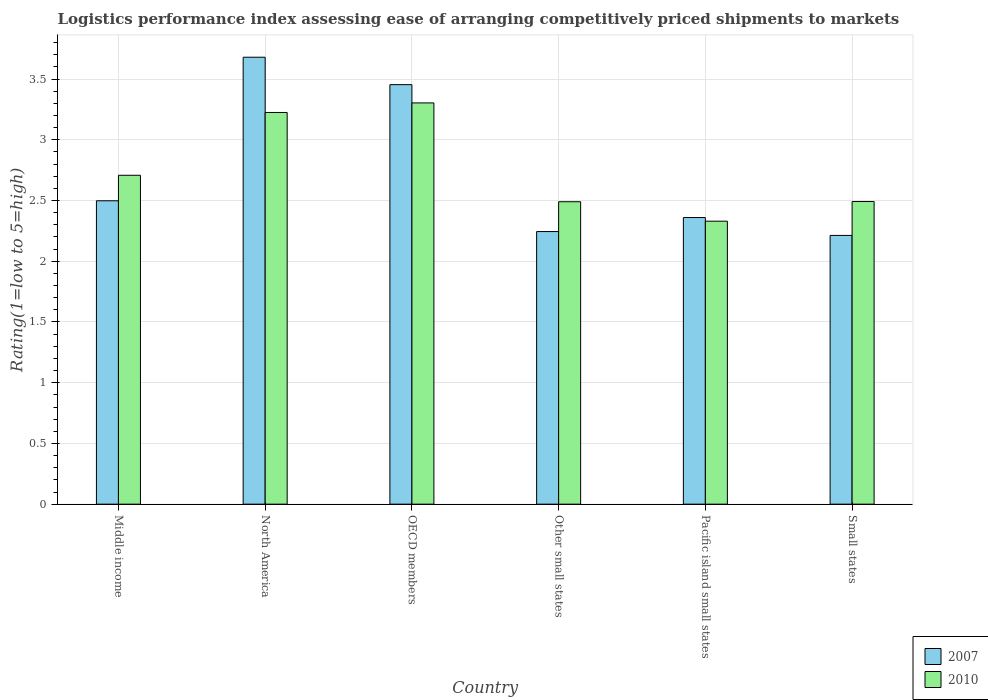How many different coloured bars are there?
Give a very brief answer. 2. How many bars are there on the 4th tick from the right?
Provide a short and direct response. 2. What is the label of the 5th group of bars from the left?
Ensure brevity in your answer.  Pacific island small states. In how many cases, is the number of bars for a given country not equal to the number of legend labels?
Keep it short and to the point. 0. What is the Logistic performance index in 2010 in North America?
Give a very brief answer. 3.23. Across all countries, what is the maximum Logistic performance index in 2010?
Your answer should be very brief. 3.3. Across all countries, what is the minimum Logistic performance index in 2010?
Provide a succinct answer. 2.33. In which country was the Logistic performance index in 2007 maximum?
Your response must be concise. North America. In which country was the Logistic performance index in 2010 minimum?
Your answer should be very brief. Pacific island small states. What is the total Logistic performance index in 2010 in the graph?
Offer a very short reply. 16.55. What is the difference between the Logistic performance index in 2010 in North America and that in Small states?
Provide a succinct answer. 0.73. What is the difference between the Logistic performance index in 2010 in Pacific island small states and the Logistic performance index in 2007 in OECD members?
Your answer should be very brief. -1.12. What is the average Logistic performance index in 2007 per country?
Offer a very short reply. 2.74. What is the difference between the Logistic performance index of/in 2010 and Logistic performance index of/in 2007 in North America?
Give a very brief answer. -0.46. What is the ratio of the Logistic performance index in 2007 in OECD members to that in Other small states?
Offer a very short reply. 1.54. Is the Logistic performance index in 2007 in Other small states less than that in Pacific island small states?
Give a very brief answer. Yes. Is the difference between the Logistic performance index in 2010 in OECD members and Pacific island small states greater than the difference between the Logistic performance index in 2007 in OECD members and Pacific island small states?
Provide a short and direct response. No. What is the difference between the highest and the second highest Logistic performance index in 2010?
Offer a very short reply. 0.52. What is the difference between the highest and the lowest Logistic performance index in 2007?
Keep it short and to the point. 1.47. What does the 2nd bar from the right in Other small states represents?
Offer a terse response. 2007. How many bars are there?
Ensure brevity in your answer.  12. Are all the bars in the graph horizontal?
Make the answer very short. No. How many countries are there in the graph?
Make the answer very short. 6. What is the difference between two consecutive major ticks on the Y-axis?
Offer a terse response. 0.5. Does the graph contain any zero values?
Make the answer very short. No. Does the graph contain grids?
Give a very brief answer. Yes. Where does the legend appear in the graph?
Give a very brief answer. Bottom right. How many legend labels are there?
Provide a succinct answer. 2. What is the title of the graph?
Offer a terse response. Logistics performance index assessing ease of arranging competitively priced shipments to markets. What is the label or title of the X-axis?
Provide a short and direct response. Country. What is the label or title of the Y-axis?
Offer a terse response. Rating(1=low to 5=high). What is the Rating(1=low to 5=high) in 2007 in Middle income?
Your response must be concise. 2.5. What is the Rating(1=low to 5=high) in 2010 in Middle income?
Offer a terse response. 2.71. What is the Rating(1=low to 5=high) in 2007 in North America?
Offer a terse response. 3.68. What is the Rating(1=low to 5=high) of 2010 in North America?
Make the answer very short. 3.23. What is the Rating(1=low to 5=high) in 2007 in OECD members?
Keep it short and to the point. 3.45. What is the Rating(1=low to 5=high) of 2010 in OECD members?
Give a very brief answer. 3.3. What is the Rating(1=low to 5=high) in 2007 in Other small states?
Your answer should be compact. 2.24. What is the Rating(1=low to 5=high) in 2010 in Other small states?
Your response must be concise. 2.49. What is the Rating(1=low to 5=high) of 2007 in Pacific island small states?
Ensure brevity in your answer.  2.36. What is the Rating(1=low to 5=high) of 2010 in Pacific island small states?
Your response must be concise. 2.33. What is the Rating(1=low to 5=high) of 2007 in Small states?
Provide a succinct answer. 2.21. What is the Rating(1=low to 5=high) in 2010 in Small states?
Ensure brevity in your answer.  2.49. Across all countries, what is the maximum Rating(1=low to 5=high) of 2007?
Provide a succinct answer. 3.68. Across all countries, what is the maximum Rating(1=low to 5=high) of 2010?
Provide a short and direct response. 3.3. Across all countries, what is the minimum Rating(1=low to 5=high) in 2007?
Make the answer very short. 2.21. Across all countries, what is the minimum Rating(1=low to 5=high) in 2010?
Offer a terse response. 2.33. What is the total Rating(1=low to 5=high) of 2007 in the graph?
Make the answer very short. 16.45. What is the total Rating(1=low to 5=high) in 2010 in the graph?
Ensure brevity in your answer.  16.55. What is the difference between the Rating(1=low to 5=high) in 2007 in Middle income and that in North America?
Offer a very short reply. -1.18. What is the difference between the Rating(1=low to 5=high) of 2010 in Middle income and that in North America?
Provide a short and direct response. -0.52. What is the difference between the Rating(1=low to 5=high) in 2007 in Middle income and that in OECD members?
Your response must be concise. -0.96. What is the difference between the Rating(1=low to 5=high) in 2010 in Middle income and that in OECD members?
Provide a succinct answer. -0.6. What is the difference between the Rating(1=low to 5=high) in 2007 in Middle income and that in Other small states?
Keep it short and to the point. 0.25. What is the difference between the Rating(1=low to 5=high) of 2010 in Middle income and that in Other small states?
Your response must be concise. 0.22. What is the difference between the Rating(1=low to 5=high) in 2007 in Middle income and that in Pacific island small states?
Offer a terse response. 0.14. What is the difference between the Rating(1=low to 5=high) of 2010 in Middle income and that in Pacific island small states?
Ensure brevity in your answer.  0.38. What is the difference between the Rating(1=low to 5=high) in 2007 in Middle income and that in Small states?
Offer a terse response. 0.29. What is the difference between the Rating(1=low to 5=high) of 2010 in Middle income and that in Small states?
Keep it short and to the point. 0.22. What is the difference between the Rating(1=low to 5=high) in 2007 in North America and that in OECD members?
Provide a short and direct response. 0.23. What is the difference between the Rating(1=low to 5=high) of 2010 in North America and that in OECD members?
Your answer should be very brief. -0.08. What is the difference between the Rating(1=low to 5=high) of 2007 in North America and that in Other small states?
Keep it short and to the point. 1.44. What is the difference between the Rating(1=low to 5=high) of 2010 in North America and that in Other small states?
Give a very brief answer. 0.73. What is the difference between the Rating(1=low to 5=high) in 2007 in North America and that in Pacific island small states?
Ensure brevity in your answer.  1.32. What is the difference between the Rating(1=low to 5=high) of 2010 in North America and that in Pacific island small states?
Give a very brief answer. 0.9. What is the difference between the Rating(1=low to 5=high) of 2007 in North America and that in Small states?
Provide a succinct answer. 1.47. What is the difference between the Rating(1=low to 5=high) of 2010 in North America and that in Small states?
Make the answer very short. 0.73. What is the difference between the Rating(1=low to 5=high) in 2007 in OECD members and that in Other small states?
Your answer should be very brief. 1.21. What is the difference between the Rating(1=low to 5=high) in 2010 in OECD members and that in Other small states?
Your answer should be compact. 0.81. What is the difference between the Rating(1=low to 5=high) in 2007 in OECD members and that in Pacific island small states?
Make the answer very short. 1.09. What is the difference between the Rating(1=low to 5=high) of 2010 in OECD members and that in Pacific island small states?
Give a very brief answer. 0.97. What is the difference between the Rating(1=low to 5=high) in 2007 in OECD members and that in Small states?
Your response must be concise. 1.24. What is the difference between the Rating(1=low to 5=high) of 2010 in OECD members and that in Small states?
Your answer should be compact. 0.81. What is the difference between the Rating(1=low to 5=high) in 2007 in Other small states and that in Pacific island small states?
Offer a very short reply. -0.12. What is the difference between the Rating(1=low to 5=high) of 2010 in Other small states and that in Pacific island small states?
Your response must be concise. 0.16. What is the difference between the Rating(1=low to 5=high) in 2007 in Other small states and that in Small states?
Keep it short and to the point. 0.03. What is the difference between the Rating(1=low to 5=high) in 2010 in Other small states and that in Small states?
Your answer should be very brief. -0. What is the difference between the Rating(1=low to 5=high) in 2007 in Pacific island small states and that in Small states?
Provide a short and direct response. 0.15. What is the difference between the Rating(1=low to 5=high) of 2010 in Pacific island small states and that in Small states?
Provide a short and direct response. -0.16. What is the difference between the Rating(1=low to 5=high) in 2007 in Middle income and the Rating(1=low to 5=high) in 2010 in North America?
Your answer should be compact. -0.73. What is the difference between the Rating(1=low to 5=high) of 2007 in Middle income and the Rating(1=low to 5=high) of 2010 in OECD members?
Offer a very short reply. -0.81. What is the difference between the Rating(1=low to 5=high) in 2007 in Middle income and the Rating(1=low to 5=high) in 2010 in Other small states?
Your answer should be very brief. 0.01. What is the difference between the Rating(1=low to 5=high) of 2007 in Middle income and the Rating(1=low to 5=high) of 2010 in Pacific island small states?
Offer a very short reply. 0.17. What is the difference between the Rating(1=low to 5=high) in 2007 in Middle income and the Rating(1=low to 5=high) in 2010 in Small states?
Make the answer very short. 0.01. What is the difference between the Rating(1=low to 5=high) in 2007 in North America and the Rating(1=low to 5=high) in 2010 in OECD members?
Make the answer very short. 0.38. What is the difference between the Rating(1=low to 5=high) of 2007 in North America and the Rating(1=low to 5=high) of 2010 in Other small states?
Provide a succinct answer. 1.19. What is the difference between the Rating(1=low to 5=high) of 2007 in North America and the Rating(1=low to 5=high) of 2010 in Pacific island small states?
Make the answer very short. 1.35. What is the difference between the Rating(1=low to 5=high) in 2007 in North America and the Rating(1=low to 5=high) in 2010 in Small states?
Provide a succinct answer. 1.19. What is the difference between the Rating(1=low to 5=high) of 2007 in OECD members and the Rating(1=low to 5=high) of 2010 in Other small states?
Ensure brevity in your answer.  0.96. What is the difference between the Rating(1=low to 5=high) of 2007 in OECD members and the Rating(1=low to 5=high) of 2010 in Pacific island small states?
Keep it short and to the point. 1.12. What is the difference between the Rating(1=low to 5=high) of 2007 in OECD members and the Rating(1=low to 5=high) of 2010 in Small states?
Provide a succinct answer. 0.96. What is the difference between the Rating(1=low to 5=high) in 2007 in Other small states and the Rating(1=low to 5=high) in 2010 in Pacific island small states?
Provide a short and direct response. -0.09. What is the difference between the Rating(1=low to 5=high) in 2007 in Other small states and the Rating(1=low to 5=high) in 2010 in Small states?
Provide a short and direct response. -0.25. What is the difference between the Rating(1=low to 5=high) in 2007 in Pacific island small states and the Rating(1=low to 5=high) in 2010 in Small states?
Provide a succinct answer. -0.13. What is the average Rating(1=low to 5=high) in 2007 per country?
Your answer should be very brief. 2.74. What is the average Rating(1=low to 5=high) of 2010 per country?
Ensure brevity in your answer.  2.76. What is the difference between the Rating(1=low to 5=high) in 2007 and Rating(1=low to 5=high) in 2010 in Middle income?
Give a very brief answer. -0.21. What is the difference between the Rating(1=low to 5=high) in 2007 and Rating(1=low to 5=high) in 2010 in North America?
Your answer should be very brief. 0.46. What is the difference between the Rating(1=low to 5=high) of 2007 and Rating(1=low to 5=high) of 2010 in OECD members?
Offer a very short reply. 0.15. What is the difference between the Rating(1=low to 5=high) of 2007 and Rating(1=low to 5=high) of 2010 in Other small states?
Provide a short and direct response. -0.25. What is the difference between the Rating(1=low to 5=high) in 2007 and Rating(1=low to 5=high) in 2010 in Small states?
Your answer should be compact. -0.28. What is the ratio of the Rating(1=low to 5=high) in 2007 in Middle income to that in North America?
Offer a very short reply. 0.68. What is the ratio of the Rating(1=low to 5=high) in 2010 in Middle income to that in North America?
Offer a very short reply. 0.84. What is the ratio of the Rating(1=low to 5=high) in 2007 in Middle income to that in OECD members?
Your answer should be very brief. 0.72. What is the ratio of the Rating(1=low to 5=high) in 2010 in Middle income to that in OECD members?
Offer a terse response. 0.82. What is the ratio of the Rating(1=low to 5=high) in 2007 in Middle income to that in Other small states?
Your answer should be very brief. 1.11. What is the ratio of the Rating(1=low to 5=high) in 2010 in Middle income to that in Other small states?
Give a very brief answer. 1.09. What is the ratio of the Rating(1=low to 5=high) in 2007 in Middle income to that in Pacific island small states?
Make the answer very short. 1.06. What is the ratio of the Rating(1=low to 5=high) in 2010 in Middle income to that in Pacific island small states?
Your answer should be very brief. 1.16. What is the ratio of the Rating(1=low to 5=high) in 2007 in Middle income to that in Small states?
Make the answer very short. 1.13. What is the ratio of the Rating(1=low to 5=high) in 2010 in Middle income to that in Small states?
Keep it short and to the point. 1.09. What is the ratio of the Rating(1=low to 5=high) of 2007 in North America to that in OECD members?
Your answer should be compact. 1.07. What is the ratio of the Rating(1=low to 5=high) in 2010 in North America to that in OECD members?
Provide a short and direct response. 0.98. What is the ratio of the Rating(1=low to 5=high) in 2007 in North America to that in Other small states?
Your answer should be compact. 1.64. What is the ratio of the Rating(1=low to 5=high) of 2010 in North America to that in Other small states?
Your answer should be very brief. 1.3. What is the ratio of the Rating(1=low to 5=high) in 2007 in North America to that in Pacific island small states?
Provide a short and direct response. 1.56. What is the ratio of the Rating(1=low to 5=high) in 2010 in North America to that in Pacific island small states?
Your response must be concise. 1.38. What is the ratio of the Rating(1=low to 5=high) in 2007 in North America to that in Small states?
Ensure brevity in your answer.  1.66. What is the ratio of the Rating(1=low to 5=high) of 2010 in North America to that in Small states?
Offer a very short reply. 1.29. What is the ratio of the Rating(1=low to 5=high) in 2007 in OECD members to that in Other small states?
Your answer should be very brief. 1.54. What is the ratio of the Rating(1=low to 5=high) in 2010 in OECD members to that in Other small states?
Your answer should be compact. 1.33. What is the ratio of the Rating(1=low to 5=high) of 2007 in OECD members to that in Pacific island small states?
Your response must be concise. 1.46. What is the ratio of the Rating(1=low to 5=high) of 2010 in OECD members to that in Pacific island small states?
Make the answer very short. 1.42. What is the ratio of the Rating(1=low to 5=high) in 2007 in OECD members to that in Small states?
Give a very brief answer. 1.56. What is the ratio of the Rating(1=low to 5=high) of 2010 in OECD members to that in Small states?
Your answer should be very brief. 1.33. What is the ratio of the Rating(1=low to 5=high) of 2007 in Other small states to that in Pacific island small states?
Offer a very short reply. 0.95. What is the ratio of the Rating(1=low to 5=high) of 2010 in Other small states to that in Pacific island small states?
Offer a very short reply. 1.07. What is the ratio of the Rating(1=low to 5=high) of 2007 in Other small states to that in Small states?
Provide a succinct answer. 1.01. What is the ratio of the Rating(1=low to 5=high) in 2007 in Pacific island small states to that in Small states?
Keep it short and to the point. 1.07. What is the ratio of the Rating(1=low to 5=high) in 2010 in Pacific island small states to that in Small states?
Ensure brevity in your answer.  0.94. What is the difference between the highest and the second highest Rating(1=low to 5=high) in 2007?
Your response must be concise. 0.23. What is the difference between the highest and the second highest Rating(1=low to 5=high) of 2010?
Your answer should be compact. 0.08. What is the difference between the highest and the lowest Rating(1=low to 5=high) in 2007?
Your answer should be very brief. 1.47. What is the difference between the highest and the lowest Rating(1=low to 5=high) of 2010?
Offer a very short reply. 0.97. 